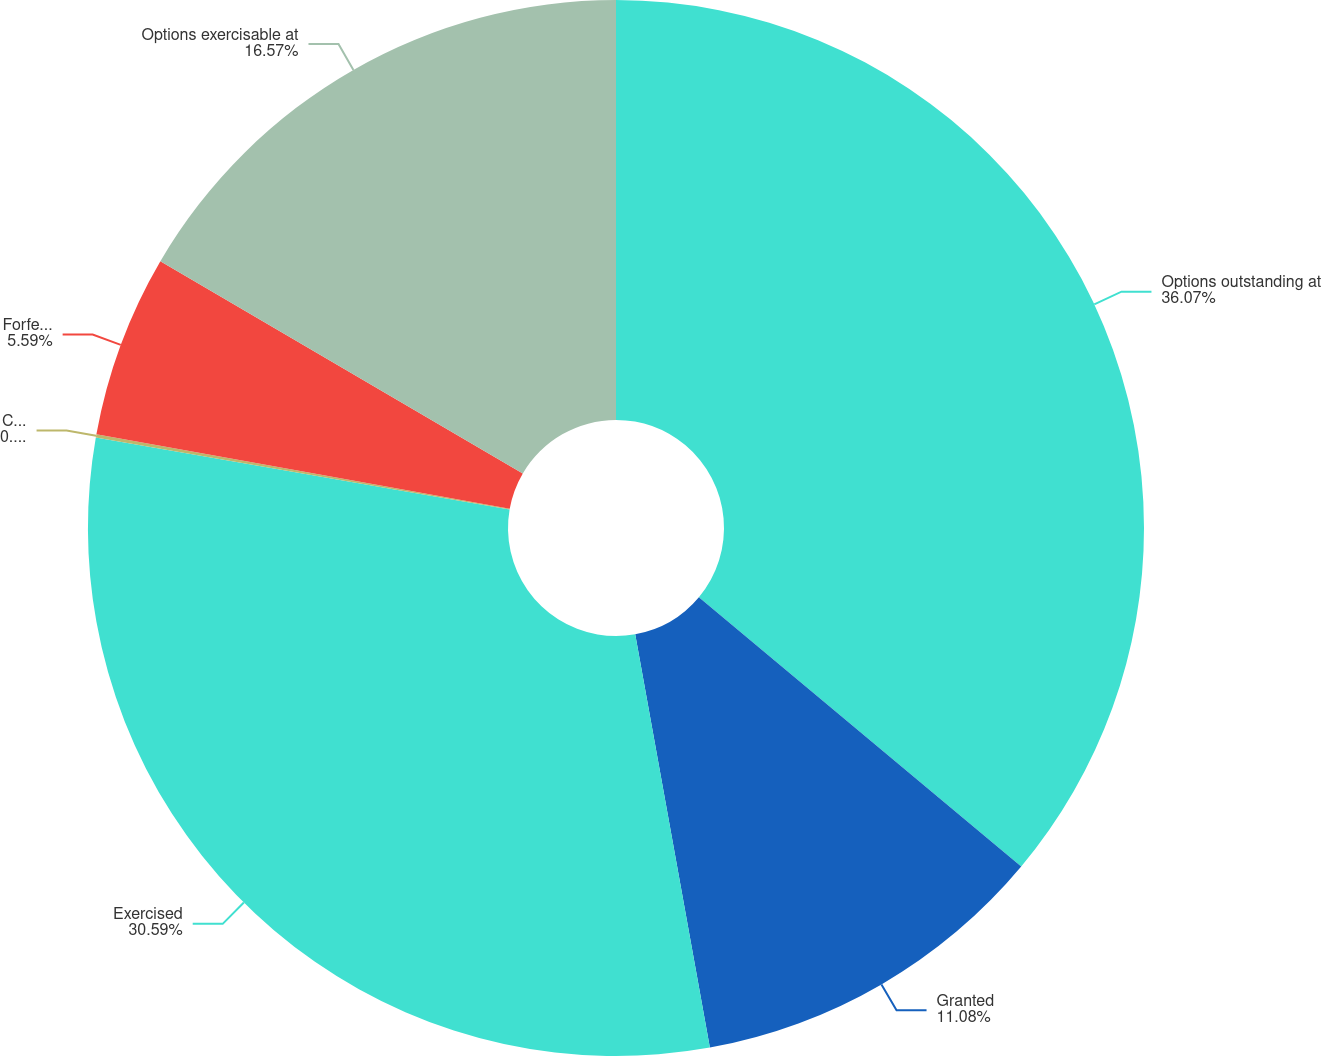Convert chart to OTSL. <chart><loc_0><loc_0><loc_500><loc_500><pie_chart><fcel>Options outstanding at<fcel>Granted<fcel>Exercised<fcel>Cancelled<fcel>Forfeited<fcel>Options exercisable at<nl><fcel>36.08%<fcel>11.08%<fcel>30.59%<fcel>0.1%<fcel>5.59%<fcel>16.57%<nl></chart> 